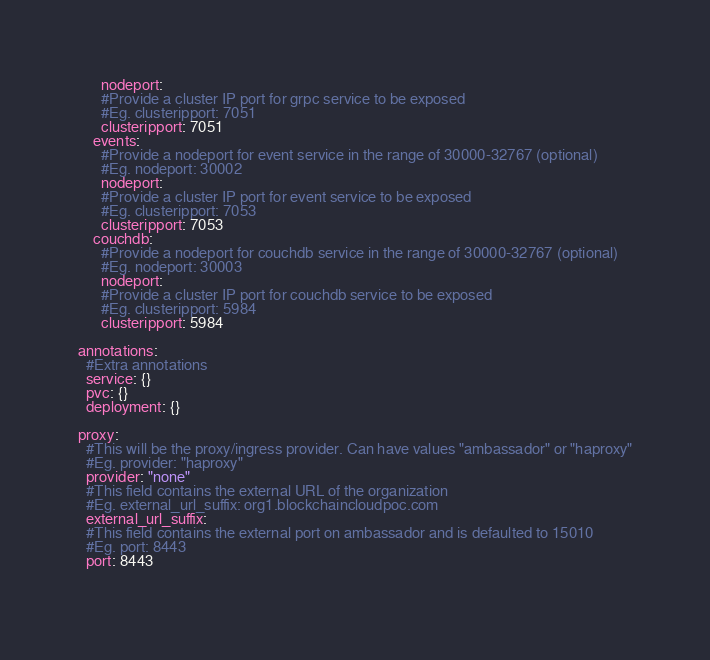Convert code to text. <code><loc_0><loc_0><loc_500><loc_500><_YAML_>      nodeport:
      #Provide a cluster IP port for grpc service to be exposed
      #Eg. clusteripport: 7051
      clusteripport: 7051
    events:
      #Provide a nodeport for event service in the range of 30000-32767 (optional)
      #Eg. nodeport: 30002
      nodeport:
      #Provide a cluster IP port for event service to be exposed
      #Eg. clusteripport: 7053
      clusteripport: 7053
    couchdb:
      #Provide a nodeport for couchdb service in the range of 30000-32767 (optional)
      #Eg. nodeport: 30003
      nodeport:
      #Provide a cluster IP port for couchdb service to be exposed
      #Eg. clusteripport: 5984
      clusteripport: 5984
      
annotations:
  #Extra annotations
  service: {}
  pvc: {}
  deployment: {}

proxy:
  #This will be the proxy/ingress provider. Can have values "ambassador" or "haproxy"
  #Eg. provider: "haproxy"
  provider: "none"
  #This field contains the external URL of the organization
  #Eg. external_url_suffix: org1.blockchaincloudpoc.com
  external_url_suffix:
  #This field contains the external port on ambassador and is defaulted to 15010
  #Eg. port: 8443
  port: 8443
  
</code> 